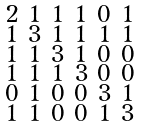<formula> <loc_0><loc_0><loc_500><loc_500>\begin{smallmatrix} 2 & 1 & 1 & 1 & 0 & 1 \\ 1 & 3 & 1 & 1 & 1 & 1 \\ 1 & 1 & 3 & 1 & 0 & 0 \\ 1 & 1 & 1 & 3 & 0 & 0 \\ 0 & 1 & 0 & 0 & 3 & 1 \\ 1 & 1 & 0 & 0 & 1 & 3 \end{smallmatrix}</formula> 